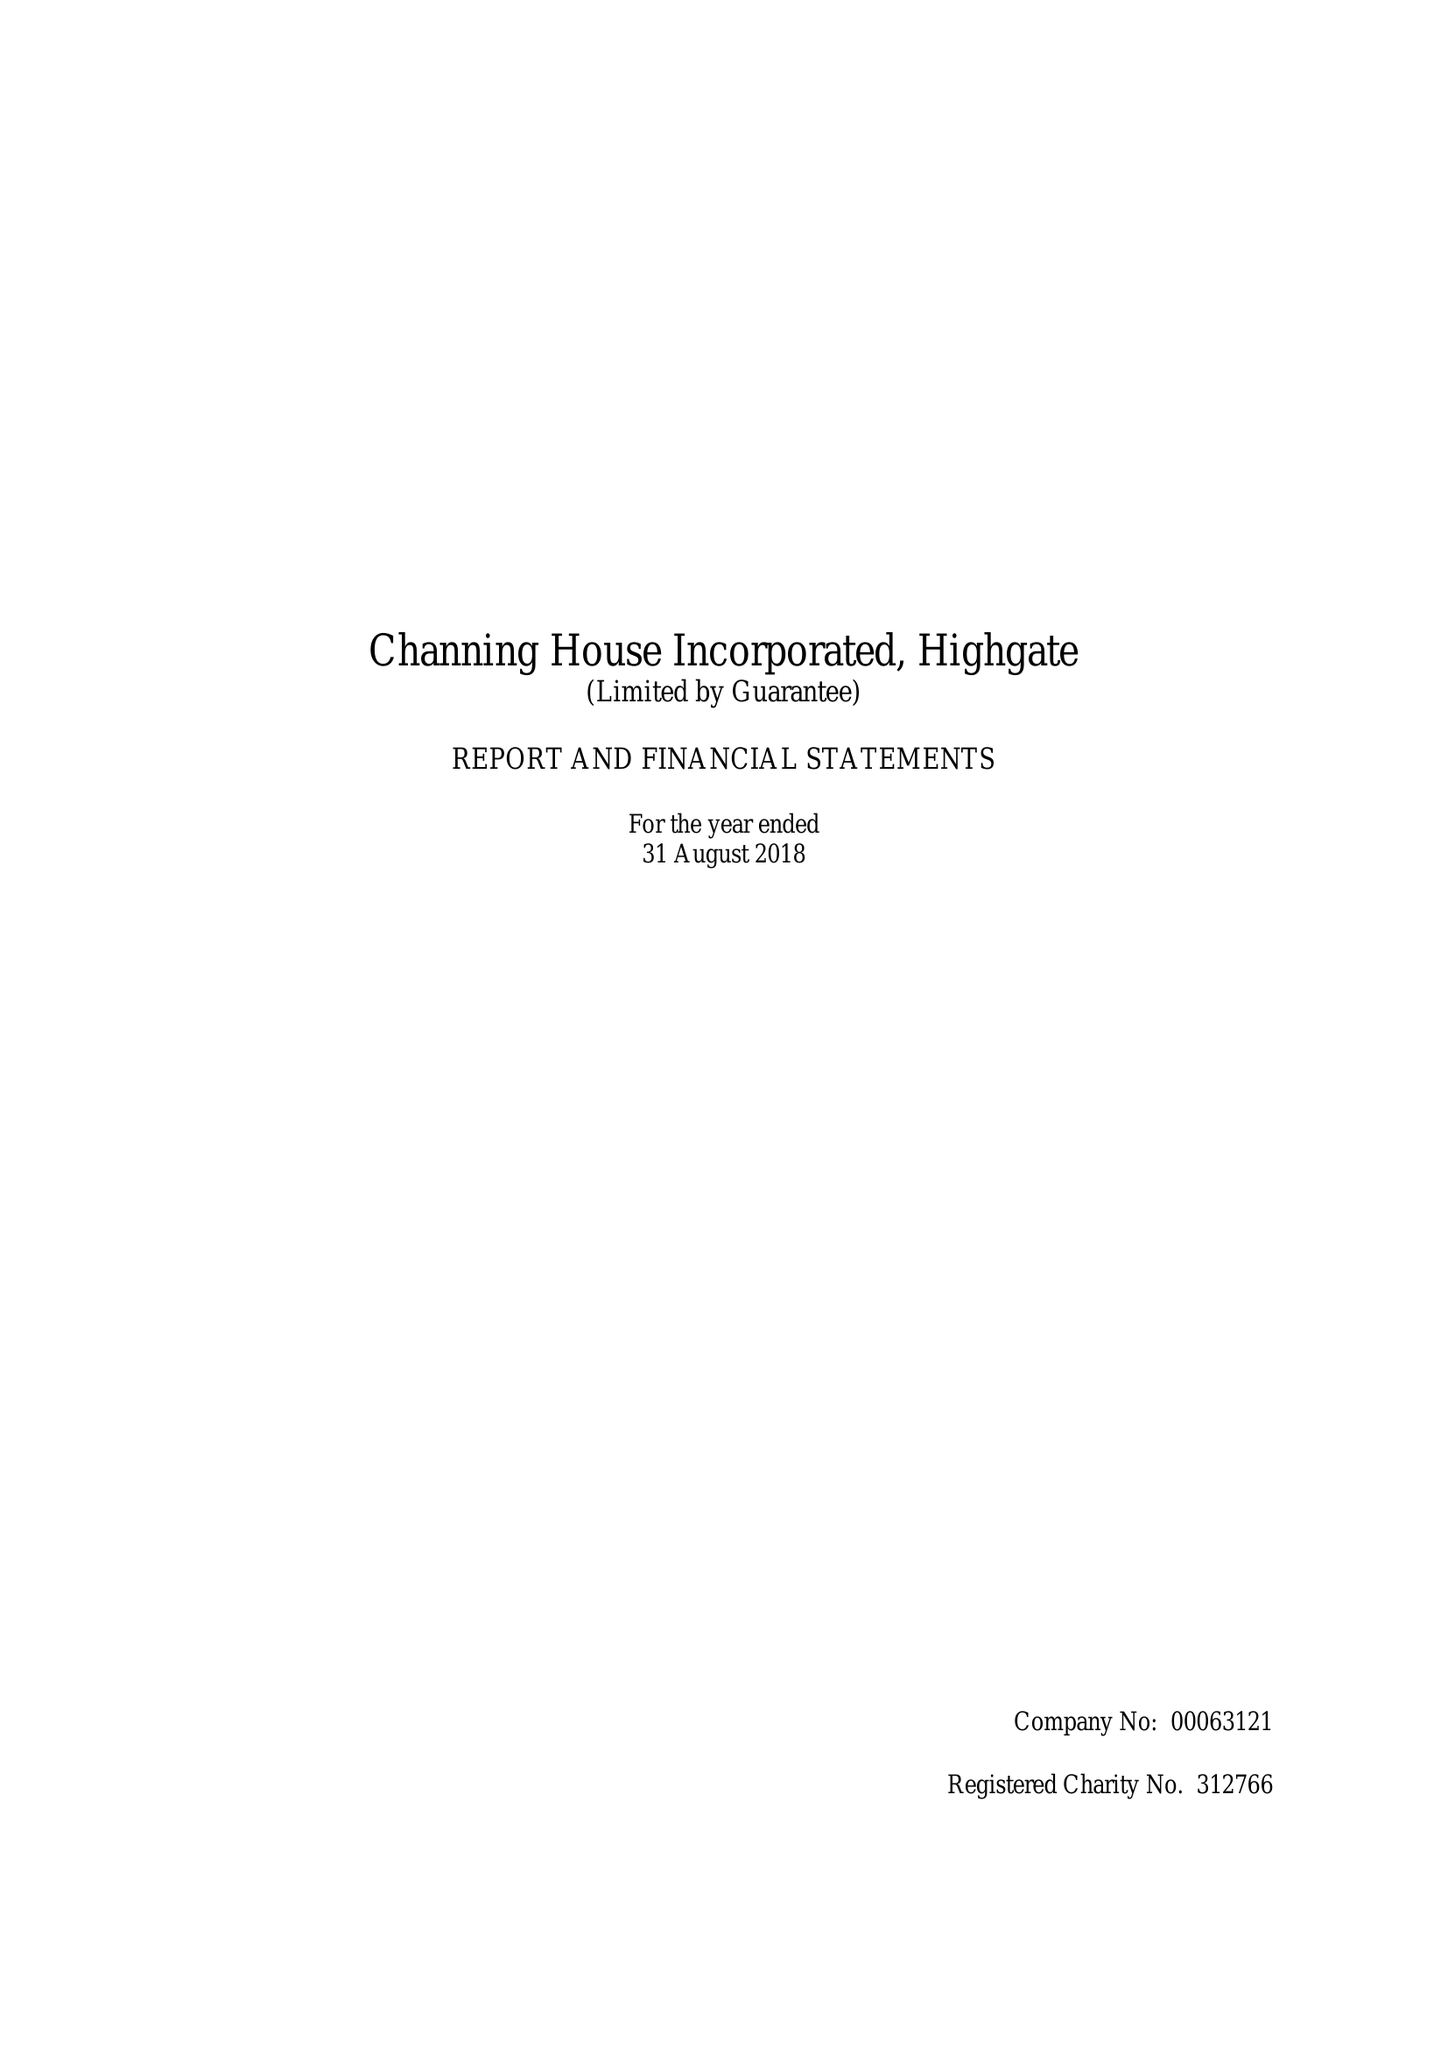What is the value for the address__post_town?
Answer the question using a single word or phrase. LONDON 